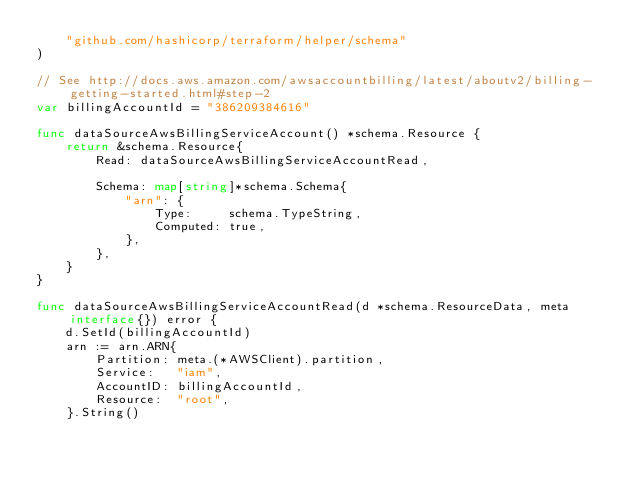<code> <loc_0><loc_0><loc_500><loc_500><_Go_>	"github.com/hashicorp/terraform/helper/schema"
)

// See http://docs.aws.amazon.com/awsaccountbilling/latest/aboutv2/billing-getting-started.html#step-2
var billingAccountId = "386209384616"

func dataSourceAwsBillingServiceAccount() *schema.Resource {
	return &schema.Resource{
		Read: dataSourceAwsBillingServiceAccountRead,

		Schema: map[string]*schema.Schema{
			"arn": {
				Type:     schema.TypeString,
				Computed: true,
			},
		},
	}
}

func dataSourceAwsBillingServiceAccountRead(d *schema.ResourceData, meta interface{}) error {
	d.SetId(billingAccountId)
	arn := arn.ARN{
		Partition: meta.(*AWSClient).partition,
		Service:   "iam",
		AccountID: billingAccountId,
		Resource:  "root",
	}.String()</code> 